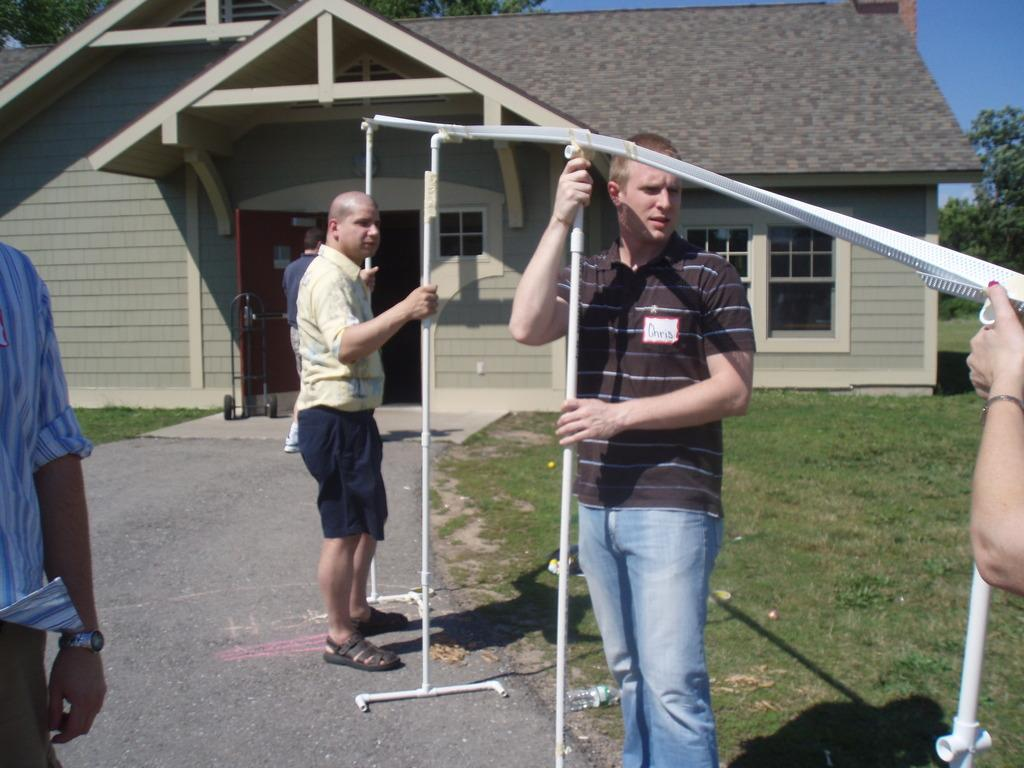What type of structure is visible in the image? There is a house in the image. What natural element is present in the image? There is a tree in the image. What are the people in the image doing? The people are standing and holding pipes in the image. What type of ground surface is visible in the image? There is grass on the ground in the image. What is the condition of the sky in the image? The sky is cloudy in the image. How does the wealth of the people in the image affect the quality of the grass? The image does not provide any information about the wealth of the people or the quality of the grass, so it is not possible to make a connection between the two. 